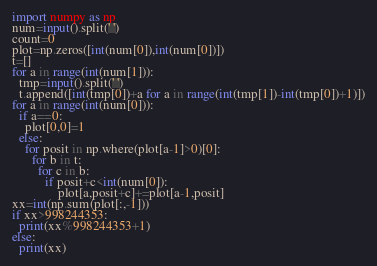Convert code to text. <code><loc_0><loc_0><loc_500><loc_500><_Python_>import numpy as np
num=input().split(' ')
count=0
plot=np.zeros([int(num[0]),int(num[0])])
t=[]
for a in range(int(num[1])):
  tmp=input().split(' ')
  t.append([int(tmp[0])+a for a in range(int(tmp[1])-int(tmp[0])+1)])
for a in range(int(num[0])):
  if a==0:
    plot[0,0]=1
  else:
    for posit in np.where(plot[a-1]>0)[0]:
      for b in t:
        for c in b:
          if posit+c<int(num[0]):
	          plot[a,posit+c]+=plot[a-1,posit]
xx=int(np.sum(plot[:,-1]))
if xx>998244353:
  print(xx%998244353+1)
else:
  print(xx)</code> 